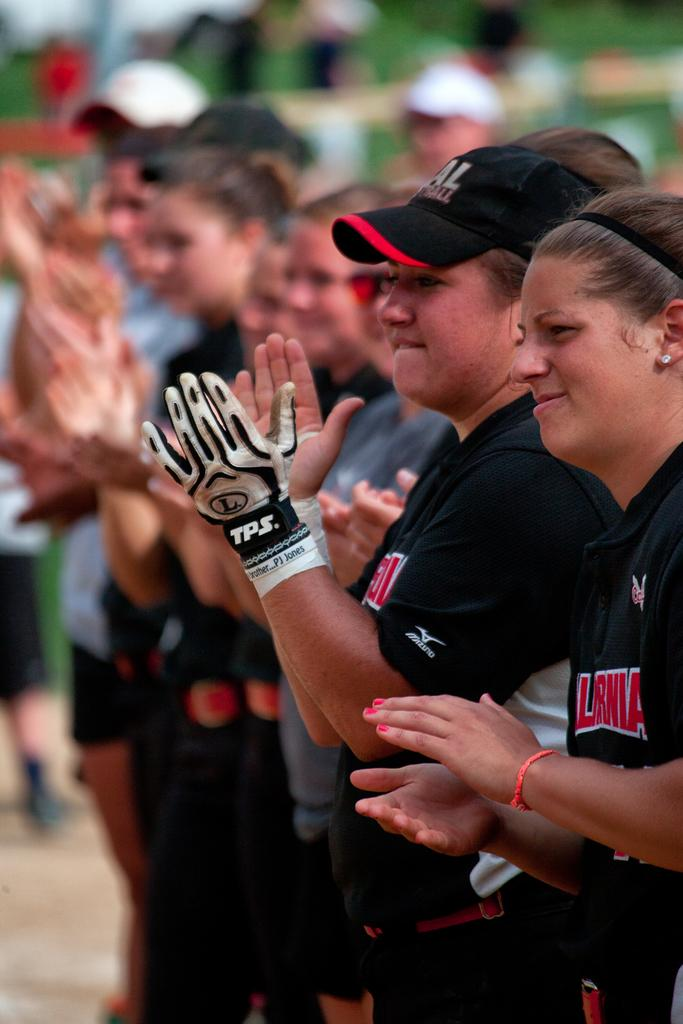Who or what is present in the image? There are people in the image. What are the people doing in the image? The people are standing and clapping. How many pizzas are being served in the image? There are no pizzas present in the image. What type of copy is being distributed in the image? There is no copy being distributed in the image; it only shows people standing and clapping. 